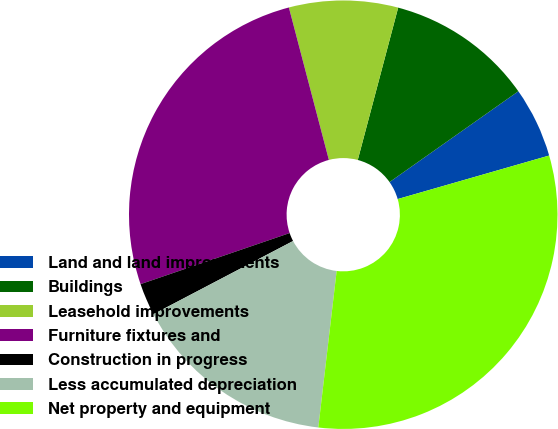Convert chart. <chart><loc_0><loc_0><loc_500><loc_500><pie_chart><fcel>Land and land improvements<fcel>Buildings<fcel>Leasehold improvements<fcel>Furniture fixtures and<fcel>Construction in progress<fcel>Less accumulated depreciation<fcel>Net property and equipment<nl><fcel>5.32%<fcel>11.1%<fcel>8.21%<fcel>26.17%<fcel>2.43%<fcel>15.46%<fcel>31.31%<nl></chart> 